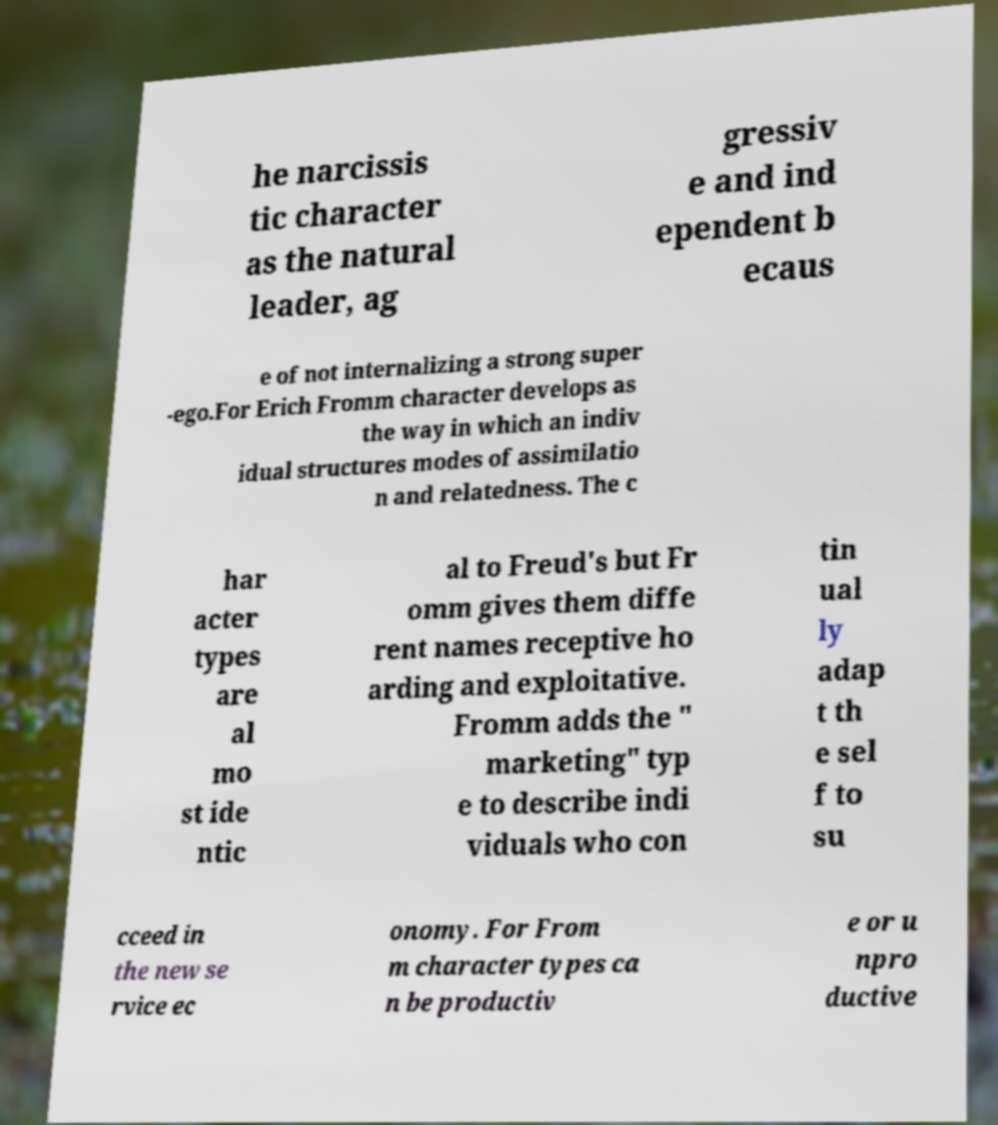What messages or text are displayed in this image? I need them in a readable, typed format. he narcissis tic character as the natural leader, ag gressiv e and ind ependent b ecaus e of not internalizing a strong super -ego.For Erich Fromm character develops as the way in which an indiv idual structures modes of assimilatio n and relatedness. The c har acter types are al mo st ide ntic al to Freud's but Fr omm gives them diffe rent names receptive ho arding and exploitative. Fromm adds the " marketing" typ e to describe indi viduals who con tin ual ly adap t th e sel f to su cceed in the new se rvice ec onomy. For From m character types ca n be productiv e or u npro ductive 